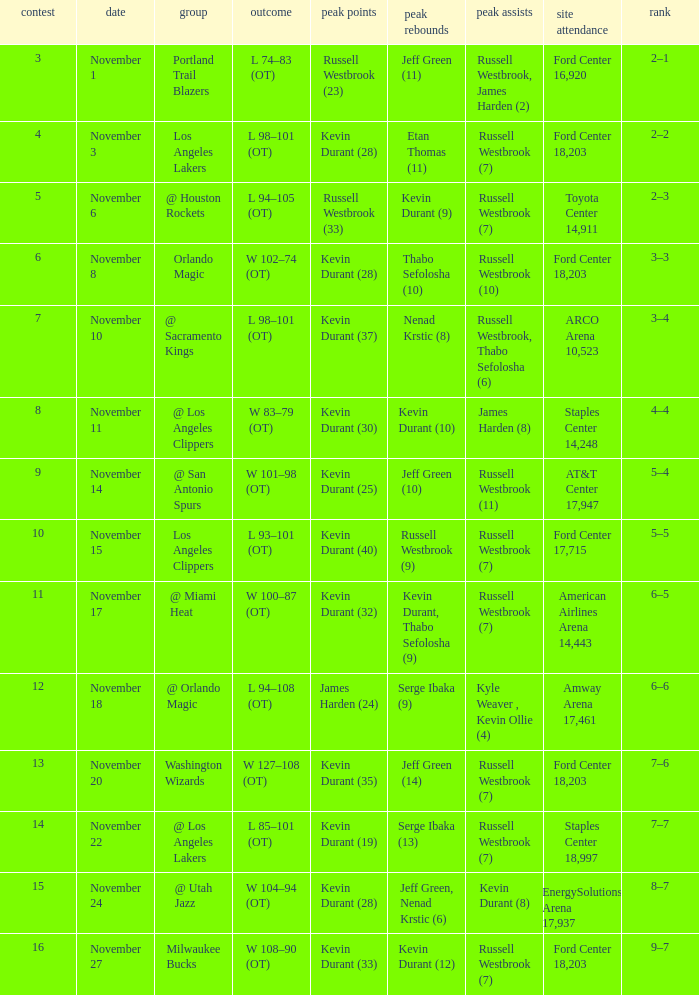Where was the game in which Kevin Durant (25) did the most high points played? AT&T Center 17,947. 